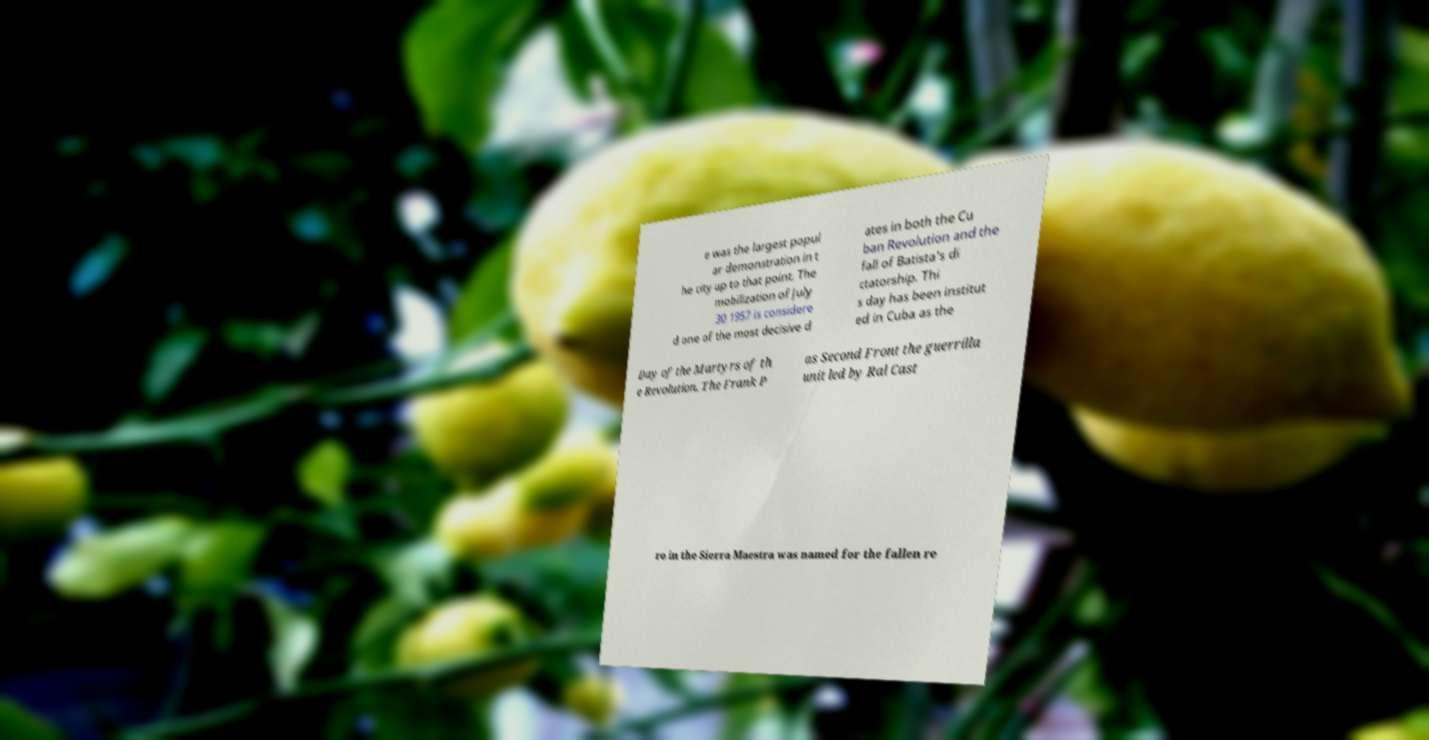Could you extract and type out the text from this image? e was the largest popul ar demonstration in t he city up to that point. The mobilization of July 30 1957 is considere d one of the most decisive d ates in both the Cu ban Revolution and the fall of Batista's di ctatorship. Thi s day has been institut ed in Cuba as the Day of the Martyrs of th e Revolution. The Frank P as Second Front the guerrilla unit led by Ral Cast ro in the Sierra Maestra was named for the fallen re 